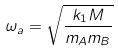Convert formula to latex. <formula><loc_0><loc_0><loc_500><loc_500>\omega _ { a } = \sqrt { \frac { k _ { 1 } M } { m _ { A } m _ { B } } }</formula> 